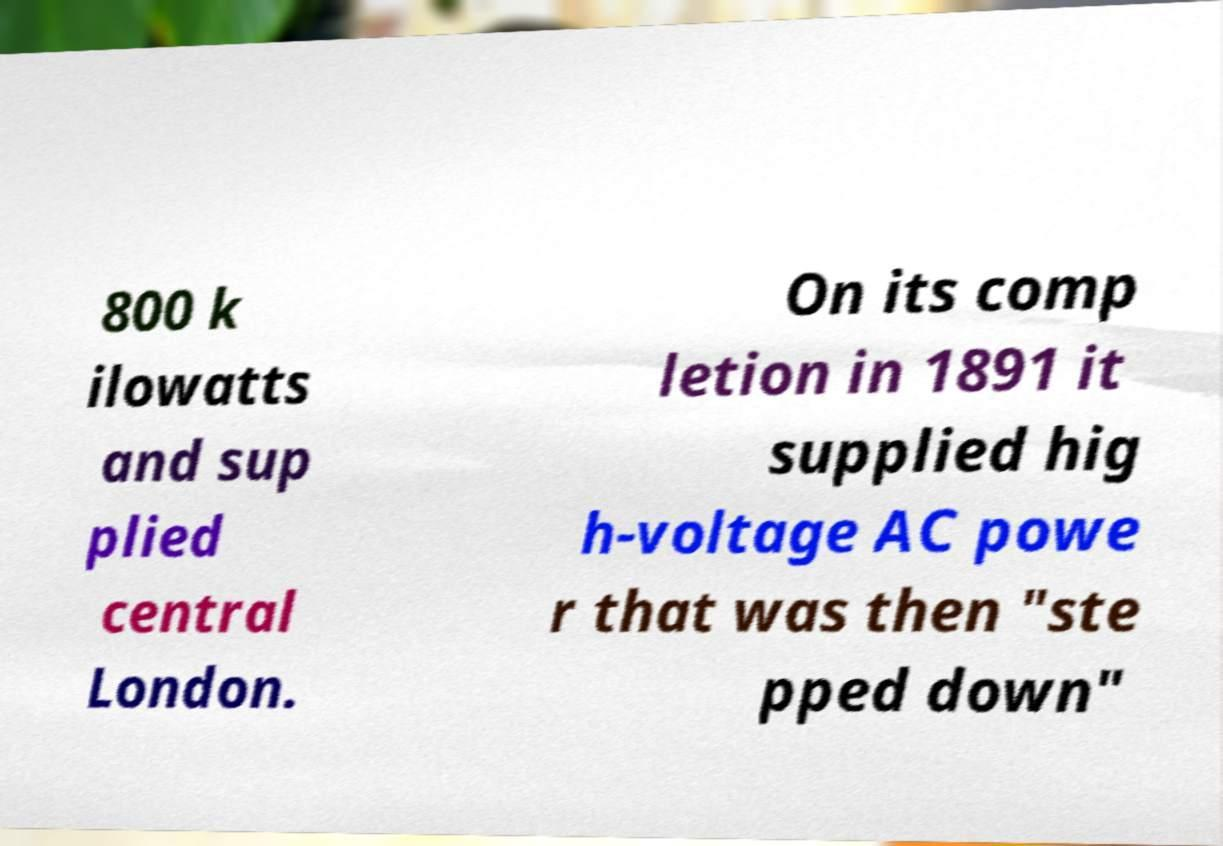What messages or text are displayed in this image? I need them in a readable, typed format. 800 k ilowatts and sup plied central London. On its comp letion in 1891 it supplied hig h-voltage AC powe r that was then "ste pped down" 